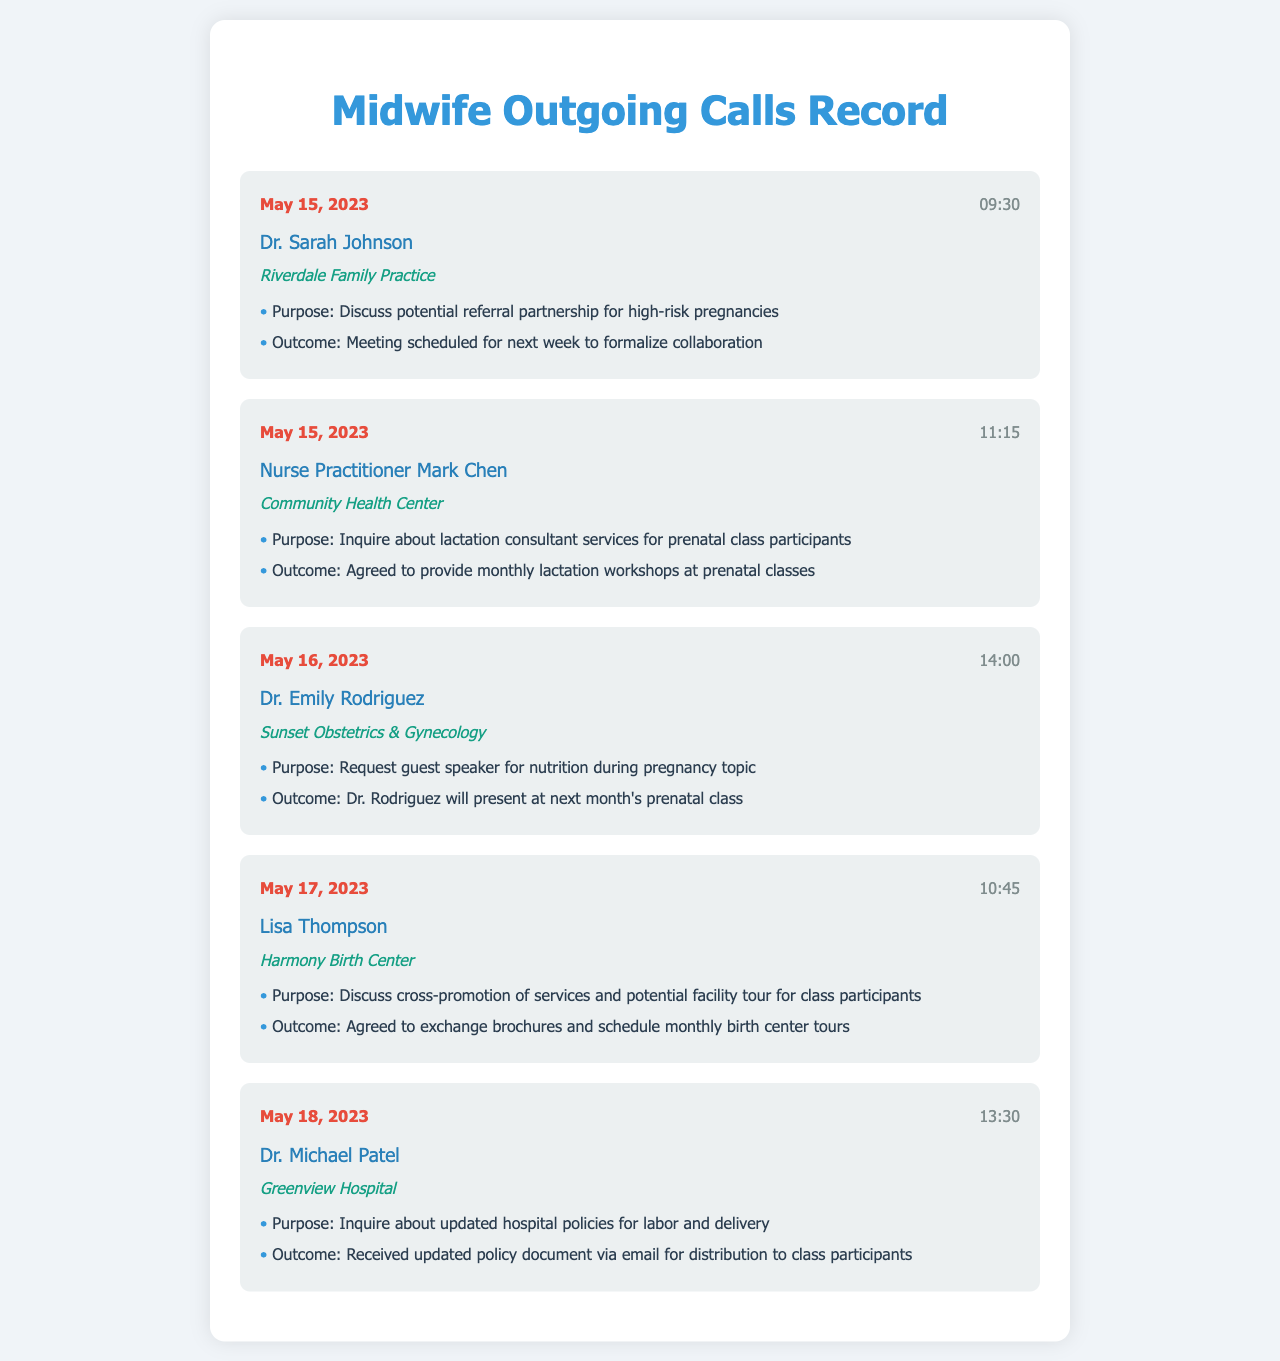What is the date of the first call? The first call in the records is dated May 15, 2023.
Answer: May 15, 2023 Who was the contact at the Community Health Center? The call for this organization was made to Nurse Practitioner Mark Chen.
Answer: Nurse Practitioner Mark Chen What was the outcome of the call with Dr. Sarah Johnson? The outcome was a meeting scheduled for next week to formalize collaboration.
Answer: Meeting scheduled for next week What was the purpose of the call to Harmony Birth Center? The purpose was to discuss cross-promotion of services and potential facility tour for class participants.
Answer: Discuss cross-promotion of services and potential facility tour How many calls were made on May 15, 2023? Two calls were made on that date, one to Dr. Sarah Johnson and another to Nurse Practitioner Mark Chen.
Answer: Two calls What organization is Dr. Emily Rodriguez associated with? Dr. Emily Rodriguez is associated with Sunset Obstetrics & Gynecology.
Answer: Sunset Obstetrics & Gynecology What topic will Dr. Rodriguez present at the next month's prenatal class? The topic is nutrition during pregnancy.
Answer: Nutrition during pregnancy What time was the call to Dr. Michael Patel? The call was made at 13:30.
Answer: 13:30 